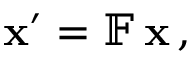Convert formula to latex. <formula><loc_0><loc_0><loc_500><loc_500>x ^ { \prime } = \mathbb { F } \, x \, ,</formula> 